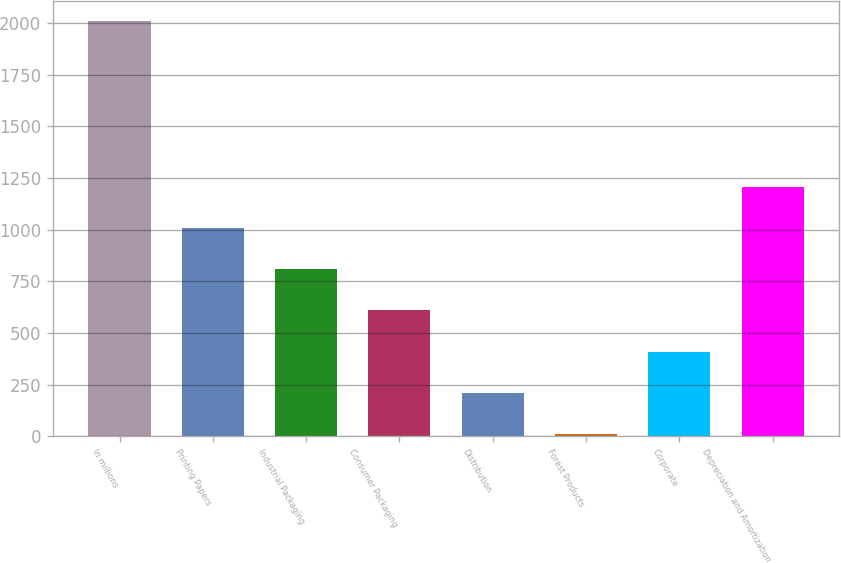Convert chart. <chart><loc_0><loc_0><loc_500><loc_500><bar_chart><fcel>In millions<fcel>Printing Papers<fcel>Industrial Packaging<fcel>Consumer Packaging<fcel>Distribution<fcel>Forest Products<fcel>Corporate<fcel>Depreciation and Amortization<nl><fcel>2007<fcel>1008.5<fcel>808.8<fcel>609.1<fcel>209.7<fcel>10<fcel>409.4<fcel>1208.2<nl></chart> 